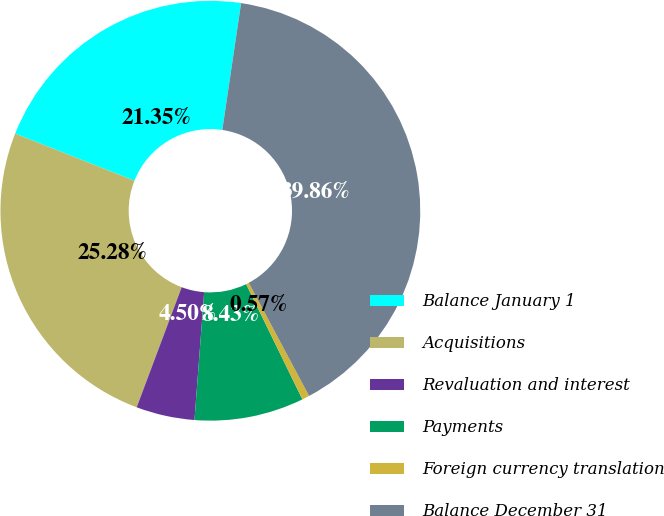<chart> <loc_0><loc_0><loc_500><loc_500><pie_chart><fcel>Balance January 1<fcel>Acquisitions<fcel>Revaluation and interest<fcel>Payments<fcel>Foreign currency translation<fcel>Balance December 31<nl><fcel>21.35%<fcel>25.28%<fcel>4.5%<fcel>8.43%<fcel>0.57%<fcel>39.86%<nl></chart> 